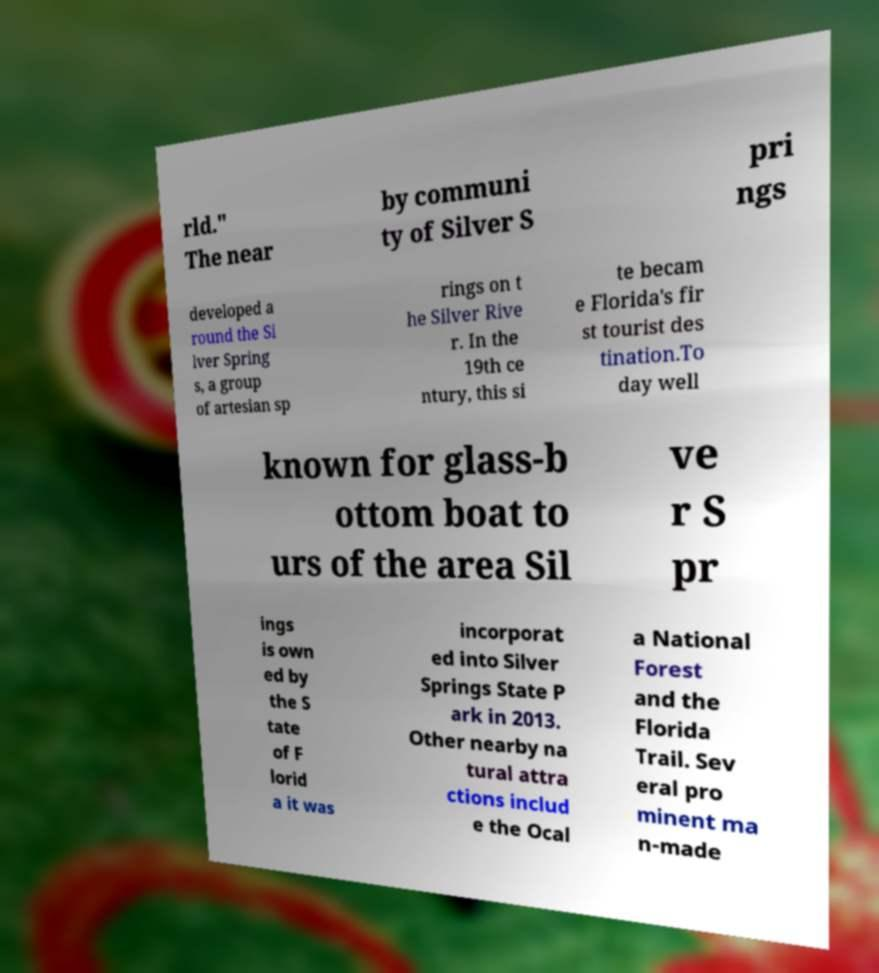There's text embedded in this image that I need extracted. Can you transcribe it verbatim? rld." The near by communi ty of Silver S pri ngs developed a round the Si lver Spring s, a group of artesian sp rings on t he Silver Rive r. In the 19th ce ntury, this si te becam e Florida's fir st tourist des tination.To day well known for glass-b ottom boat to urs of the area Sil ve r S pr ings is own ed by the S tate of F lorid a it was incorporat ed into Silver Springs State P ark in 2013. Other nearby na tural attra ctions includ e the Ocal a National Forest and the Florida Trail. Sev eral pro minent ma n-made 